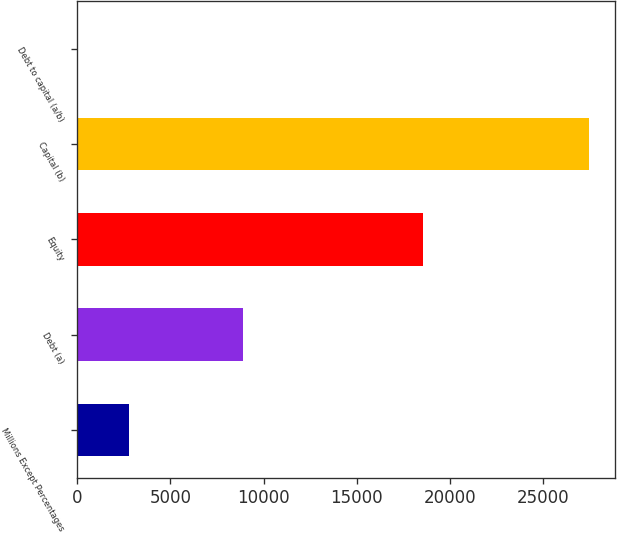Convert chart to OTSL. <chart><loc_0><loc_0><loc_500><loc_500><bar_chart><fcel>Millions Except Percentages<fcel>Debt (a)<fcel>Equity<fcel>Capital (b)<fcel>Debt to capital (a/b)<nl><fcel>2777.56<fcel>8906<fcel>18578<fcel>27484<fcel>32.4<nl></chart> 